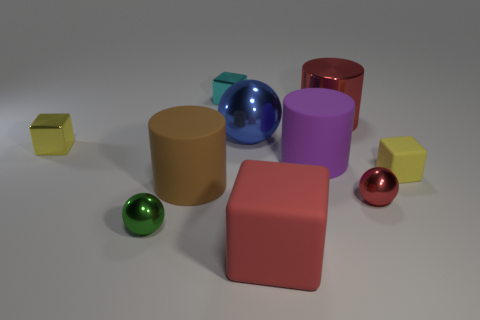There is a small yellow cube that is to the right of the cyan object; what is it made of?
Your answer should be compact. Rubber. What color is the big ball that is the same material as the red cylinder?
Offer a terse response. Blue. How many rubber objects are purple cylinders or objects?
Offer a very short reply. 4. The brown object that is the same size as the purple matte cylinder is what shape?
Offer a very short reply. Cylinder. How many objects are big things to the left of the red metal cylinder or big things that are in front of the purple object?
Give a very brief answer. 4. What material is the red ball that is the same size as the cyan metallic cube?
Ensure brevity in your answer.  Metal. How many other things are made of the same material as the brown thing?
Keep it short and to the point. 3. Are there the same number of tiny yellow blocks behind the small matte block and brown cylinders that are right of the big brown rubber cylinder?
Keep it short and to the point. No. What number of brown objects are either shiny balls or metallic cylinders?
Your response must be concise. 0. Does the large sphere have the same color as the big rubber cylinder that is on the right side of the red matte block?
Give a very brief answer. No. 